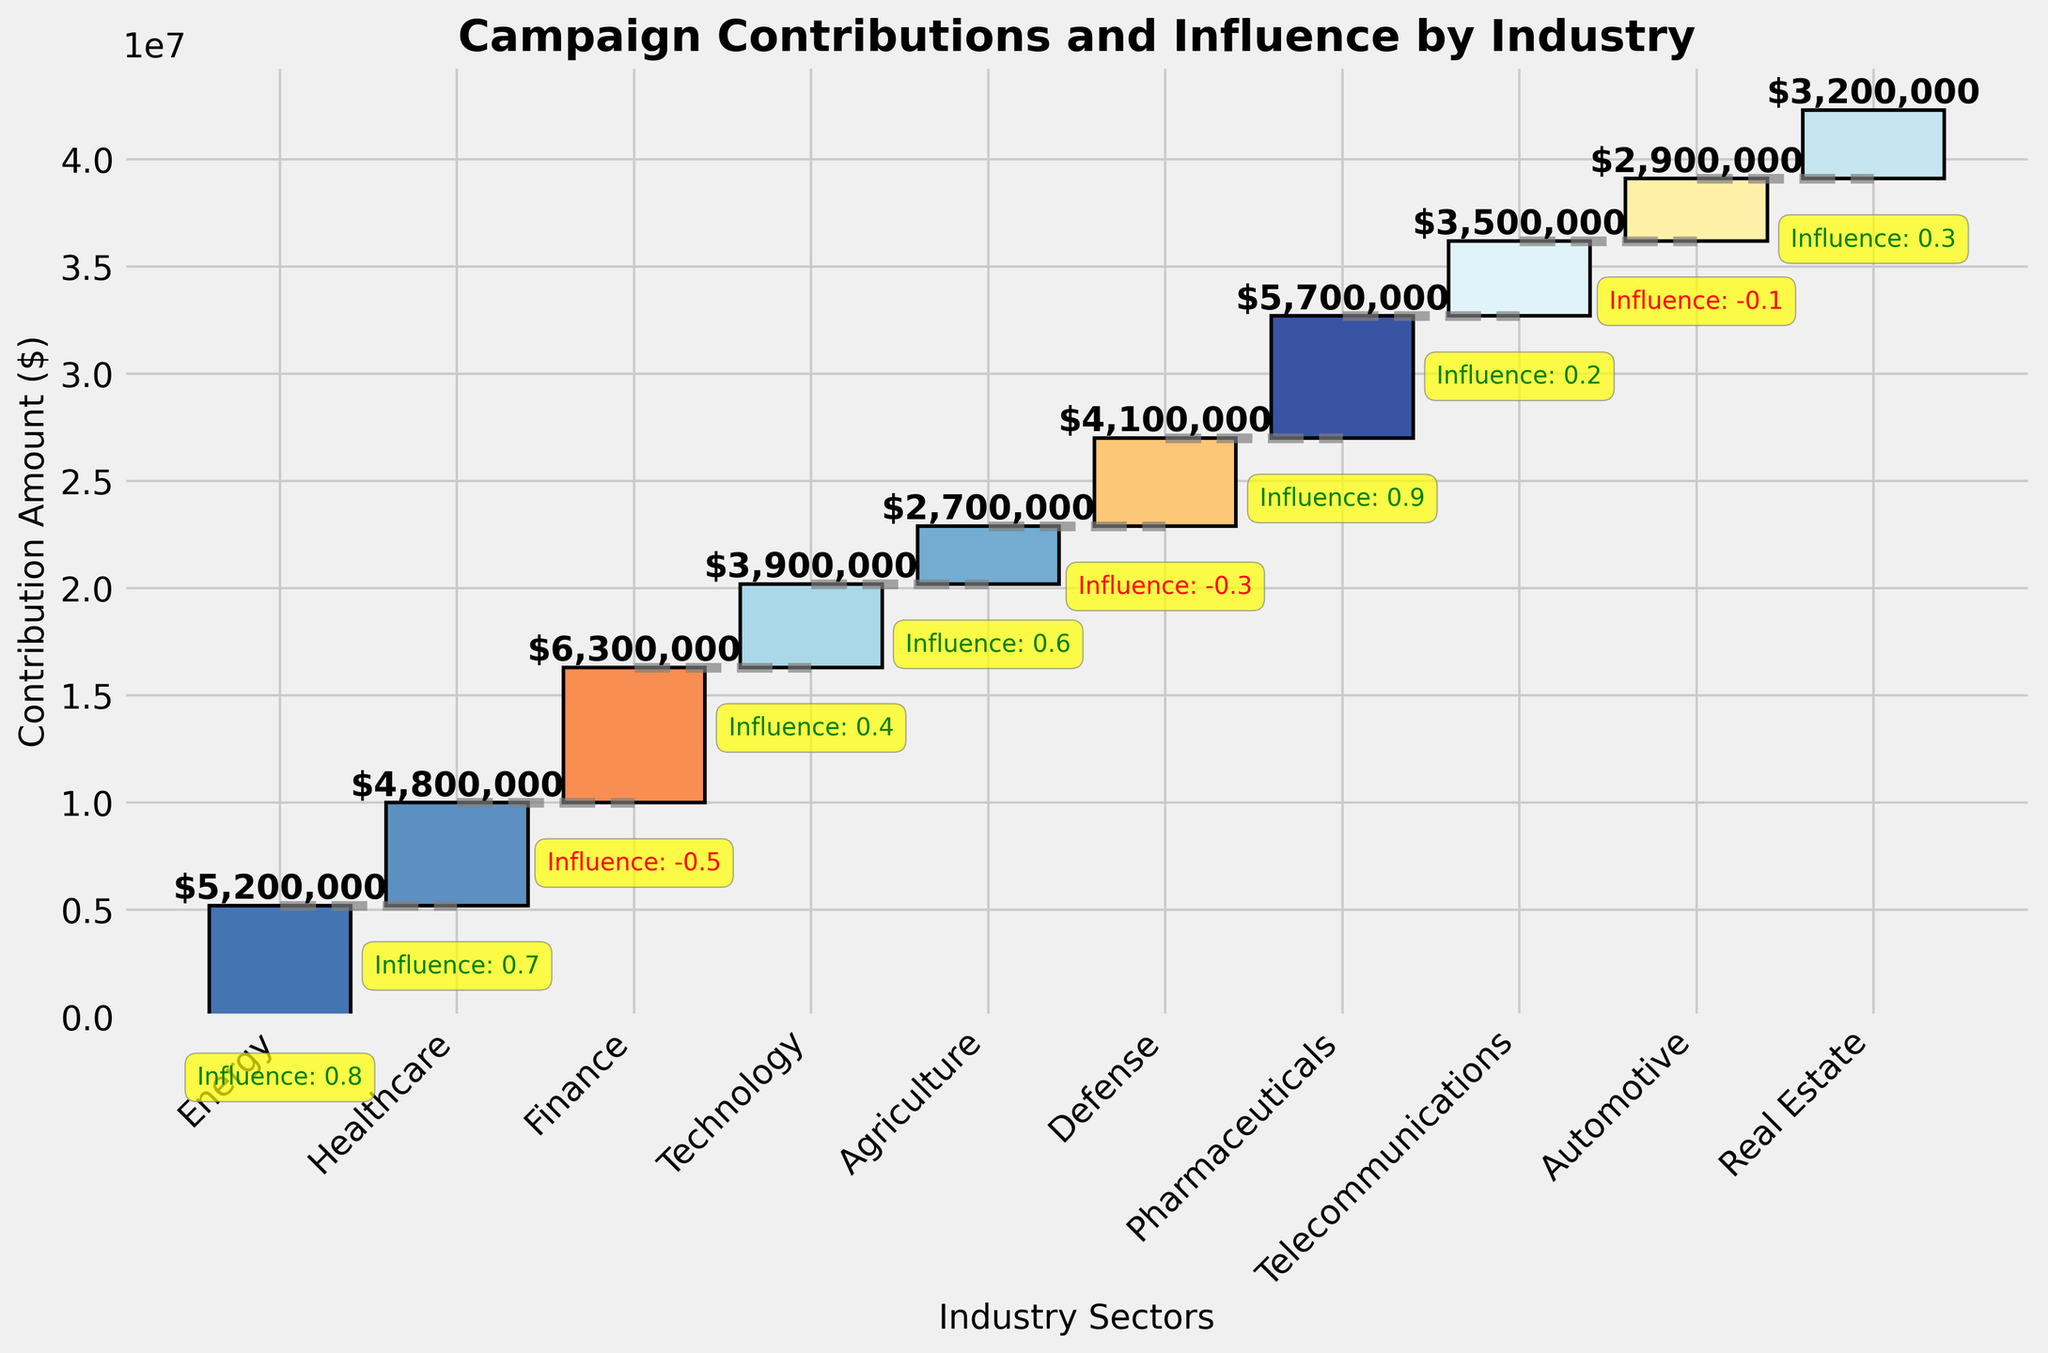What's the total contribution amount from all industries? Sum up the contribution amounts from each industry: 5,200,000 + 4,800,000 + 6,300,000 + 3,900,000 + 2,700,000 + 4,100,000 + 5,700,000 + 3,500,000 + 2,900,000 + 3,200,000 = 42,300,000
Answer: 42,300,000 Which industry sector has the highest contribution amount, and what is it? Identify the industry with the highest bar; Finance has the highest contribution amount of 6,300,000 dollars.
Answer: Finance, 6,300,000 What's the influence score of the Telecommunications industry? Check the annotation for the Telecommunications bar; it shows an influence score of 0.2.
Answer: 0.2 What is the average influence score across all industries? Sum up the influence scores and divide by the number of industries: (0.8 + 0.7 - 0.5 + 0.4 + 0.6 - 0.3 + 0.9 + 0.2 - 0.1 + 0.3) / 10 = 0.3
Answer: 0.3 Which industry has the lowest influence on legislation, and what's its influence score? Identify the industry with the lowest influence score annotation; Finance has the lowest influence score of -0.5.
Answer: Finance, -0.5 Between Energy and Agriculture, which industry has a higher contribution amount? Compare the heights of the Energy and Agriculture bars; Energy has a higher contribution amount of 5,200,000 compared to 2,700,000 for Agriculture.
Answer: Energy What's the cumulative contribution amount after adding the Healthcare industry's contributions? Cumulative sum up to Healthcare: 5,200,000 (Energy) + 4,800,000 (Healthcare) = 10,000,000
Answer: 10,000,000 Which industry with a positive influence score has the highest contribution amount? Review industries with positive influence scores and compare contribution amounts; Pharmaceuticals has the highest contribution amount of 5,700,000 among industries with a positive influence score.
Answer: Pharmaceuticals What is the cumulative contribution amount after the Defense industry's contributions are added? Cumulative sum up to Defense: 5,200,000 (Energy) + 4,800,000 (Healthcare) + 6,300,000 (Finance) + 3,900,000 (Technology) + 2,700,000 (Agriculture) + 4,100,000 (Defense) = 27,000,000
Answer: 27,000,000 